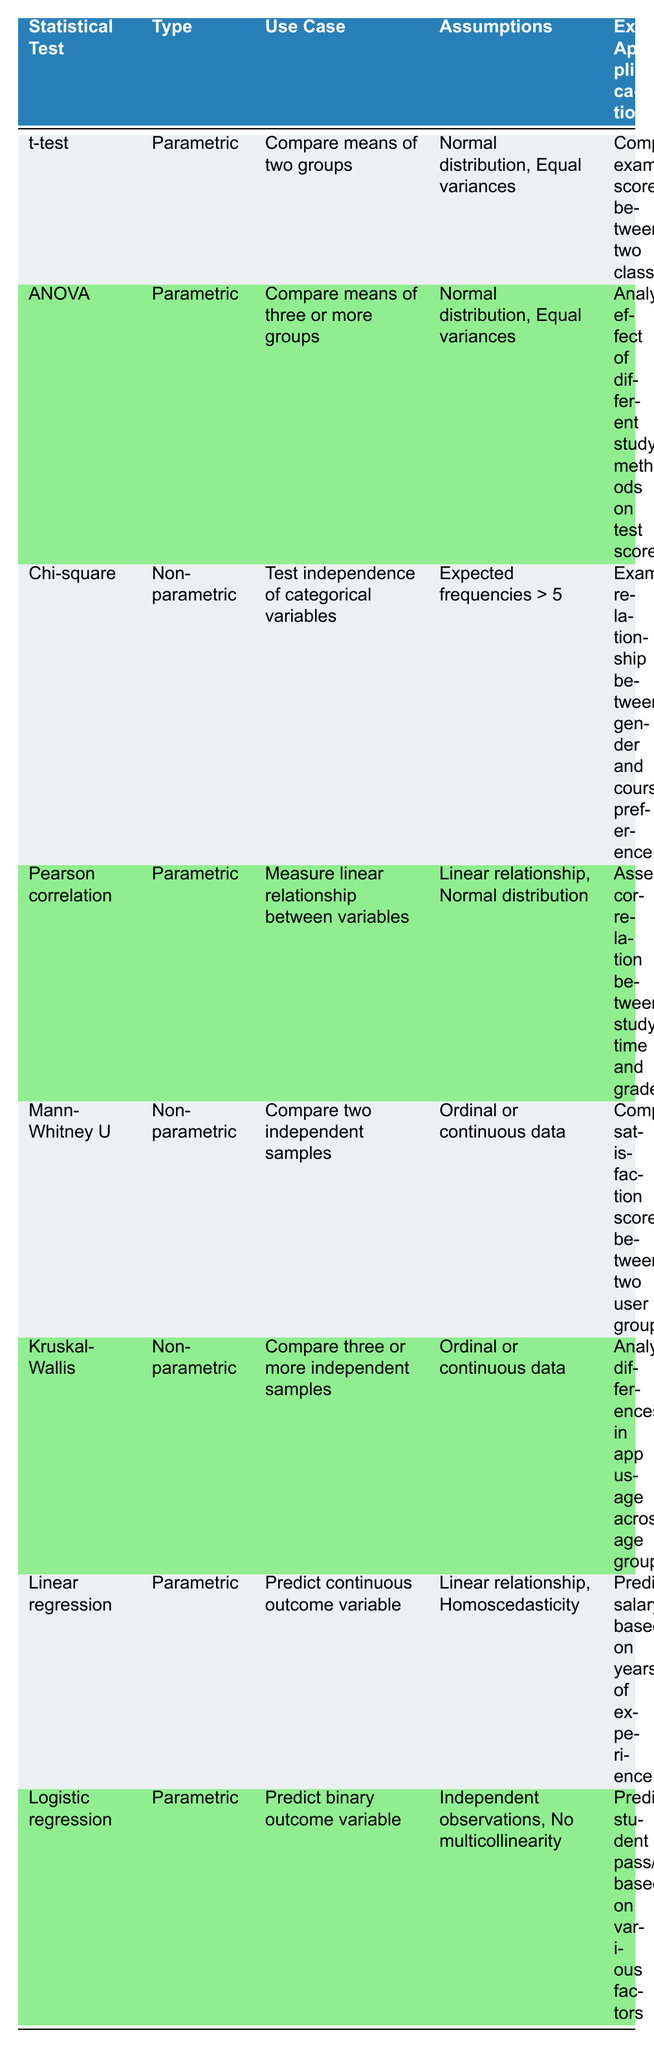What is the use case of the t-test? The table states the t-test is used to compare the means of two groups. This is found in the "Use Case" column under the t-test row.
Answer: Compare means of two groups What are the assumptions listed for ANOVA? In the table, the assumptions for ANOVA are found in the "Assumptions" column under the ANOVA row, which lists "Normal distribution, Equal variances."
Answer: Normal distribution, Equal variances Is the Mann-Whitney U test parametric or non-parametric? By looking at the table, the Mann-Whitney U test is categorized as non-parametric in the "Type" column.
Answer: Non-parametric How many statistical tests listed can be used to compare means? To find this, we look at the "Use Case" column and identify statistical tests that involve comparing means: t-test and ANOVA. This gives us a total of 2 tests.
Answer: 2 Do chi-square tests require expected frequencies to be greater than 5? Yes, the table confirms this information in the "Assumptions" column under the Chi-square row, which states "Expected frequencies > 5."
Answer: Yes Which parametric test predicts a binary outcome variable? We refer to the "Type" and "Use Case" columns, and find that logistic regression is the parametric test used for predicting a binary outcome variable. This is specifically listed under logistic regression.
Answer: Logistic regression Which test is used for analyzing differences in app usage across age groups? The table shows in the "Example Application" column under the Kruskal-Wallis row that this test is used for that purpose, as it is designed to compare three or more independent samples.
Answer: Kruskal-Wallis What do we infer about the relationship between study time and grades based on Pearson correlation? Based on the table, Pearson correlation measures the linear relationship between variables and is used to assess correlation in the specified example; thus, it indicates that study time and grades are believed to have a direct relationship.
Answer: Linear relationship How does the assumption of homoscedasticity relate to linear regression? The table states that linear regression requires the assumption of homoscedasticity, which implies that the variance of residuals should be equal across all levels of the independent variable. This is critical for valid regression results.
Answer: Assumption of equal variance in residuals 